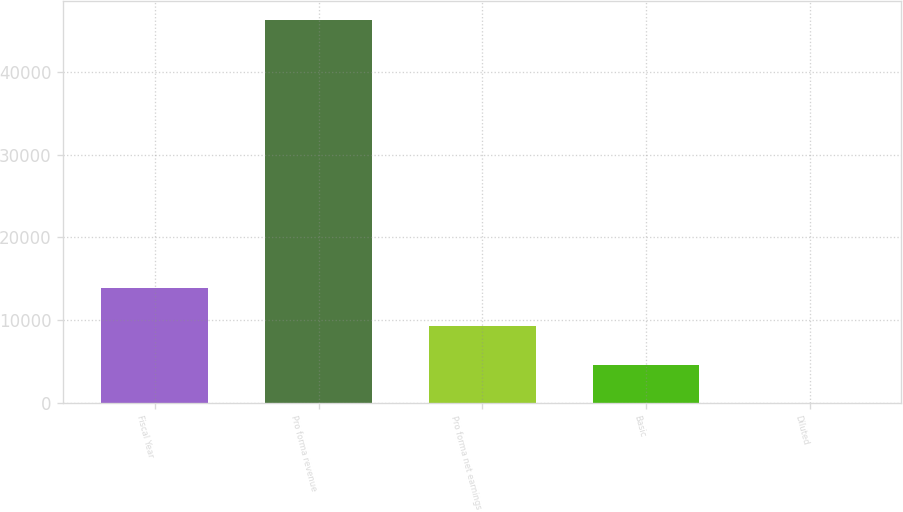Convert chart to OTSL. <chart><loc_0><loc_0><loc_500><loc_500><bar_chart><fcel>Fiscal Year<fcel>Pro forma revenue<fcel>Pro forma net earnings<fcel>Basic<fcel>Diluted<nl><fcel>13894.5<fcel>46308<fcel>9263.95<fcel>4633.45<fcel>2.95<nl></chart> 